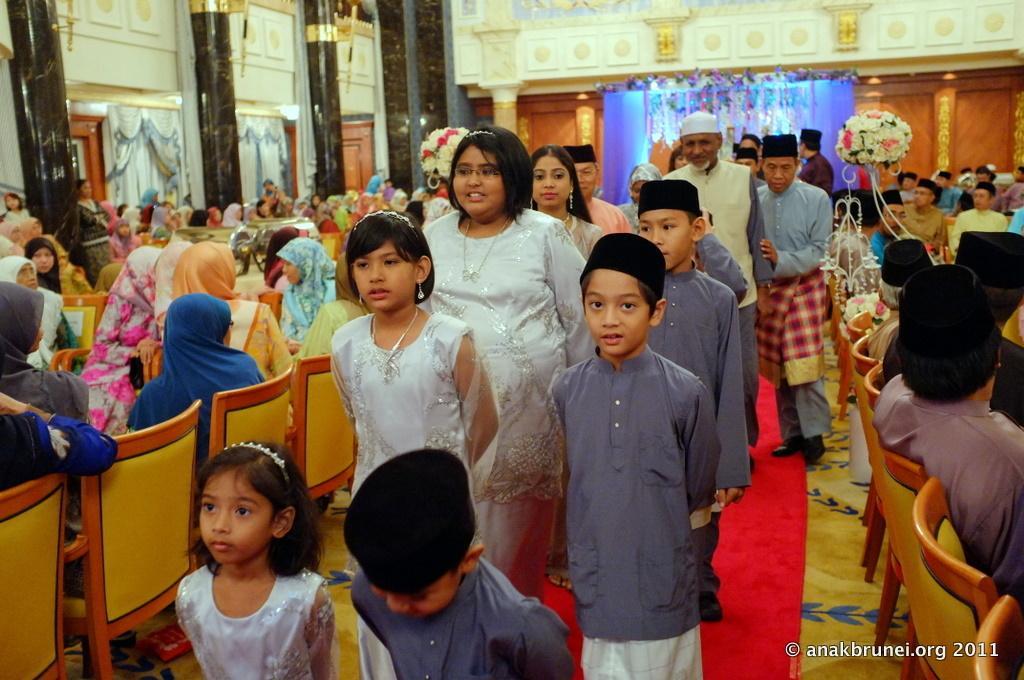Describe this image in one or two sentences. In the middle there are kids and few persons walking on the red carpet on the floor and to either side of them there are few persons sitting on the chairs. In the background there are flower vases on a platform,metal objects,decorative things,doors,wall and curtains. 